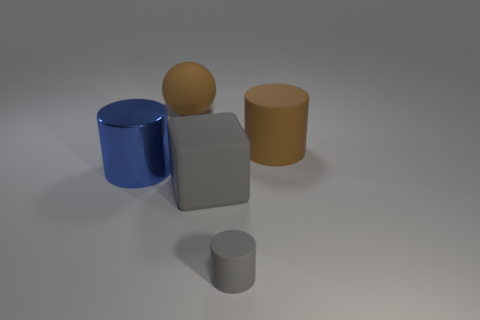Add 2 rubber cylinders. How many objects exist? 7 Subtract all cylinders. How many objects are left? 2 Add 5 gray cylinders. How many gray cylinders are left? 6 Add 2 gray cylinders. How many gray cylinders exist? 3 Subtract 0 cyan blocks. How many objects are left? 5 Subtract all yellow rubber objects. Subtract all large blue metal things. How many objects are left? 4 